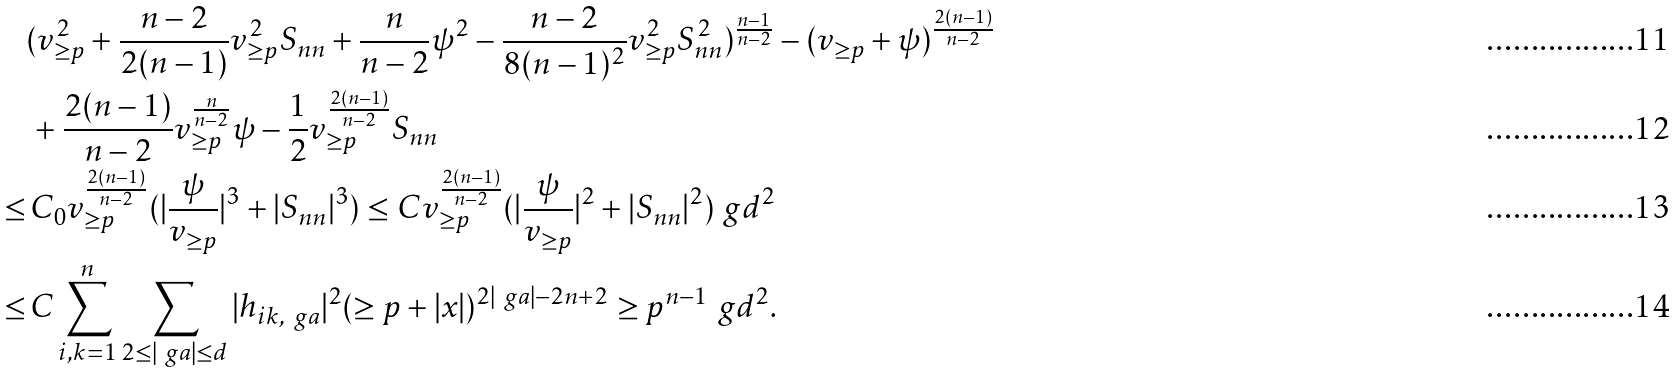Convert formula to latex. <formula><loc_0><loc_0><loc_500><loc_500>& ( v _ { \geq p } ^ { 2 } + \frac { n - 2 } { 2 ( n - 1 ) } v _ { \geq p } ^ { 2 } S _ { n n } + \frac { n } { n - 2 } \psi ^ { 2 } - \frac { n - 2 } { 8 ( n - 1 ) ^ { 2 } } v _ { \geq p } ^ { 2 } S _ { n n } ^ { 2 } ) ^ { \frac { n - 1 } { n - 2 } } - ( v _ { \geq p } + \psi ) ^ { \frac { 2 ( n - 1 ) } { n - 2 } } \\ & \, + \frac { 2 ( n - 1 ) } { n - 2 } v _ { \geq p } ^ { \frac { n } { n - 2 } } \psi - \frac { 1 } { 2 } v _ { \geq p } ^ { \frac { 2 ( n - 1 ) } { n - 2 } } S _ { n n } \\ \leq & \, C _ { 0 } v _ { \geq p } ^ { \frac { 2 ( n - 1 ) } { n - 2 } } ( | \frac { \psi } { v _ { \geq p } } | ^ { 3 } + | S _ { n n } | ^ { 3 } ) \leq C v _ { \geq p } ^ { \frac { 2 ( n - 1 ) } { n - 2 } } ( | \frac { \psi } { v _ { \geq p } } | ^ { 2 } + | S _ { n n } | ^ { 2 } ) \ g d ^ { 2 } \\ \leq & \, C \sum _ { i , k = 1 } ^ { n } \sum _ { 2 \leq | \ g a | \leq d } | h _ { i k , \ g a } | ^ { 2 } ( \geq p + | x | ) ^ { 2 | \ g a | - 2 n + 2 } \geq p ^ { n - 1 } \ g d ^ { 2 } .</formula> 